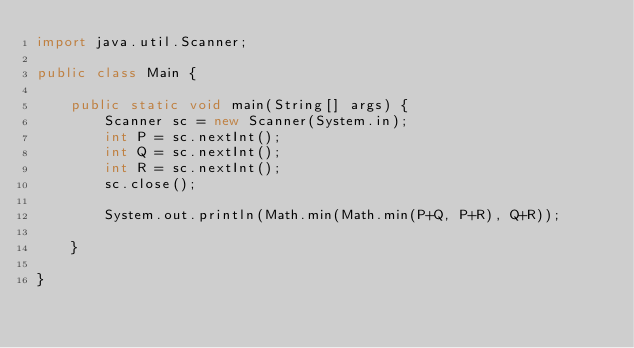Convert code to text. <code><loc_0><loc_0><loc_500><loc_500><_Java_>import java.util.Scanner;

public class Main {

	public static void main(String[] args) {
		Scanner sc = new Scanner(System.in);
	    int P = sc.nextInt();
	    int Q = sc.nextInt();
	    int R = sc.nextInt();
	    sc.close();
	    
	    System.out.println(Math.min(Math.min(P+Q, P+R), Q+R));

	}

}
</code> 